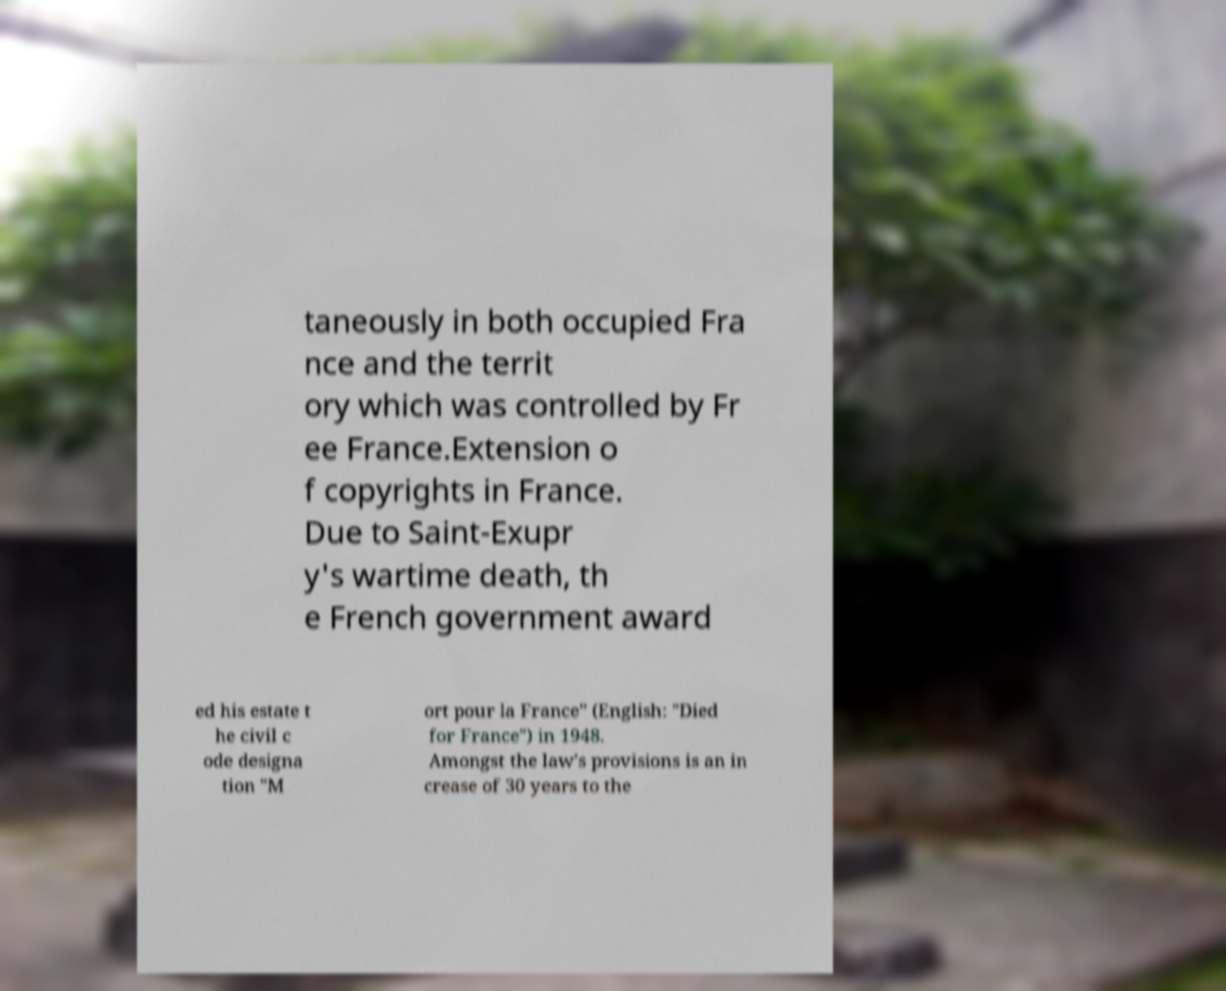What messages or text are displayed in this image? I need them in a readable, typed format. taneously in both occupied Fra nce and the territ ory which was controlled by Fr ee France.Extension o f copyrights in France. Due to Saint-Exupr y's wartime death, th e French government award ed his estate t he civil c ode designa tion "M ort pour la France" (English: "Died for France") in 1948. Amongst the law's provisions is an in crease of 30 years to the 